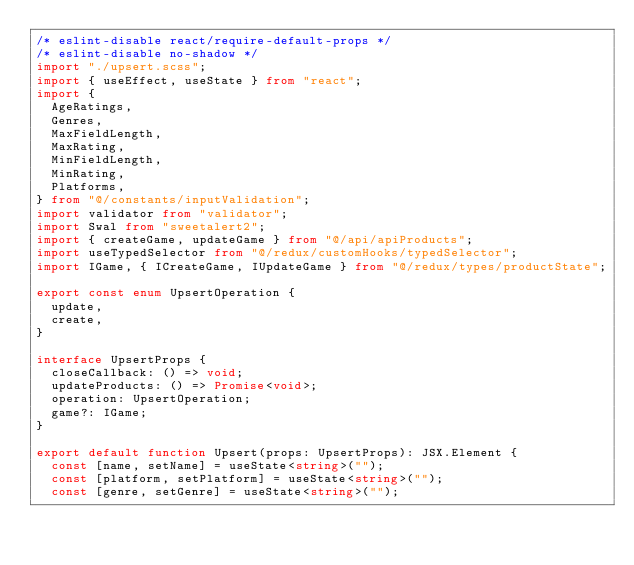<code> <loc_0><loc_0><loc_500><loc_500><_TypeScript_>/* eslint-disable react/require-default-props */
/* eslint-disable no-shadow */
import "./upsert.scss";
import { useEffect, useState } from "react";
import {
  AgeRatings,
  Genres,
  MaxFieldLength,
  MaxRating,
  MinFieldLength,
  MinRating,
  Platforms,
} from "@/constants/inputValidation";
import validator from "validator";
import Swal from "sweetalert2";
import { createGame, updateGame } from "@/api/apiProducts";
import useTypedSelector from "@/redux/customHooks/typedSelector";
import IGame, { ICreateGame, IUpdateGame } from "@/redux/types/productState";

export const enum UpsertOperation {
  update,
  create,
}

interface UpsertProps {
  closeCallback: () => void;
  updateProducts: () => Promise<void>;
  operation: UpsertOperation;
  game?: IGame;
}

export default function Upsert(props: UpsertProps): JSX.Element {
  const [name, setName] = useState<string>("");
  const [platform, setPlatform] = useState<string>("");
  const [genre, setGenre] = useState<string>("");</code> 